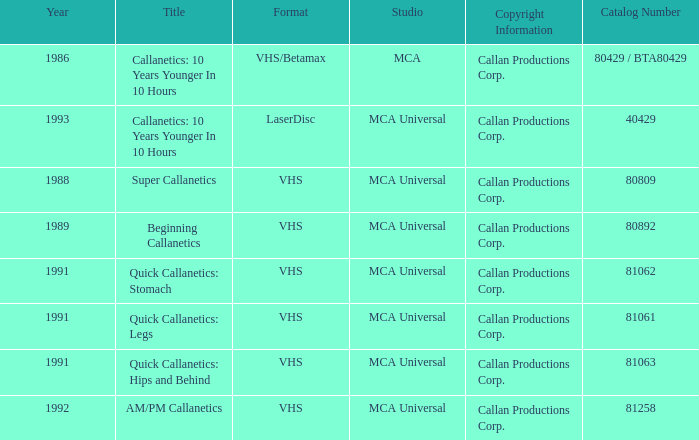Name the format for  quick callanetics: hips and behind VHS. Could you help me parse every detail presented in this table? {'header': ['Year', 'Title', 'Format', 'Studio', 'Copyright Information', 'Catalog Number'], 'rows': [['1986', 'Callanetics: 10 Years Younger In 10 Hours', 'VHS/Betamax', 'MCA', 'Callan Productions Corp.', '80429 / BTA80429'], ['1993', 'Callanetics: 10 Years Younger In 10 Hours', 'LaserDisc', 'MCA Universal', 'Callan Productions Corp.', '40429'], ['1988', 'Super Callanetics', 'VHS', 'MCA Universal', 'Callan Productions Corp.', '80809'], ['1989', 'Beginning Callanetics', 'VHS', 'MCA Universal', 'Callan Productions Corp.', '80892'], ['1991', 'Quick Callanetics: Stomach', 'VHS', 'MCA Universal', 'Callan Productions Corp.', '81062'], ['1991', 'Quick Callanetics: Legs', 'VHS', 'MCA Universal', 'Callan Productions Corp.', '81061'], ['1991', 'Quick Callanetics: Hips and Behind', 'VHS', 'MCA Universal', 'Callan Productions Corp.', '81063'], ['1992', 'AM/PM Callanetics', 'VHS', 'MCA Universal', 'Callan Productions Corp.', '81258']]} 